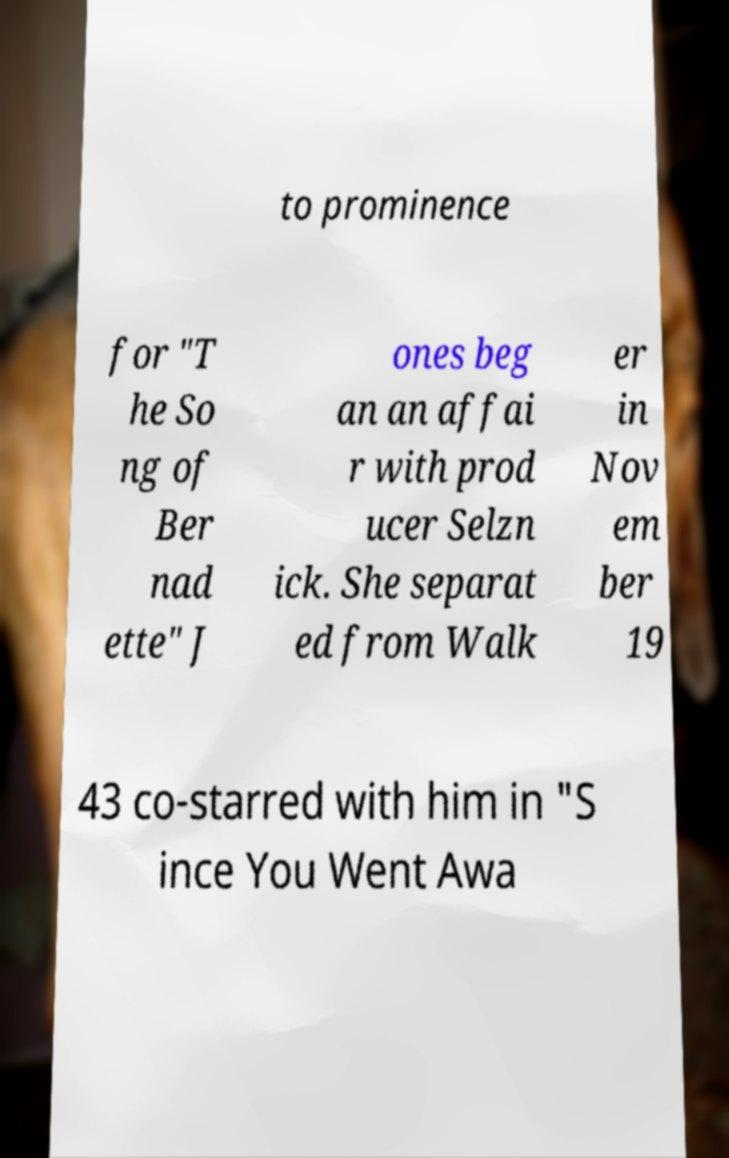I need the written content from this picture converted into text. Can you do that? to prominence for "T he So ng of Ber nad ette" J ones beg an an affai r with prod ucer Selzn ick. She separat ed from Walk er in Nov em ber 19 43 co-starred with him in "S ince You Went Awa 